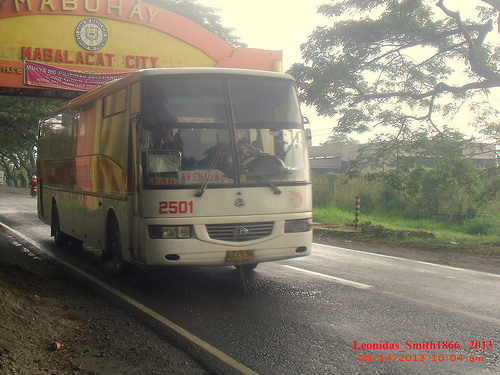<image>
Is there a banner above the mirror? No. The banner is not positioned above the mirror. The vertical arrangement shows a different relationship. 